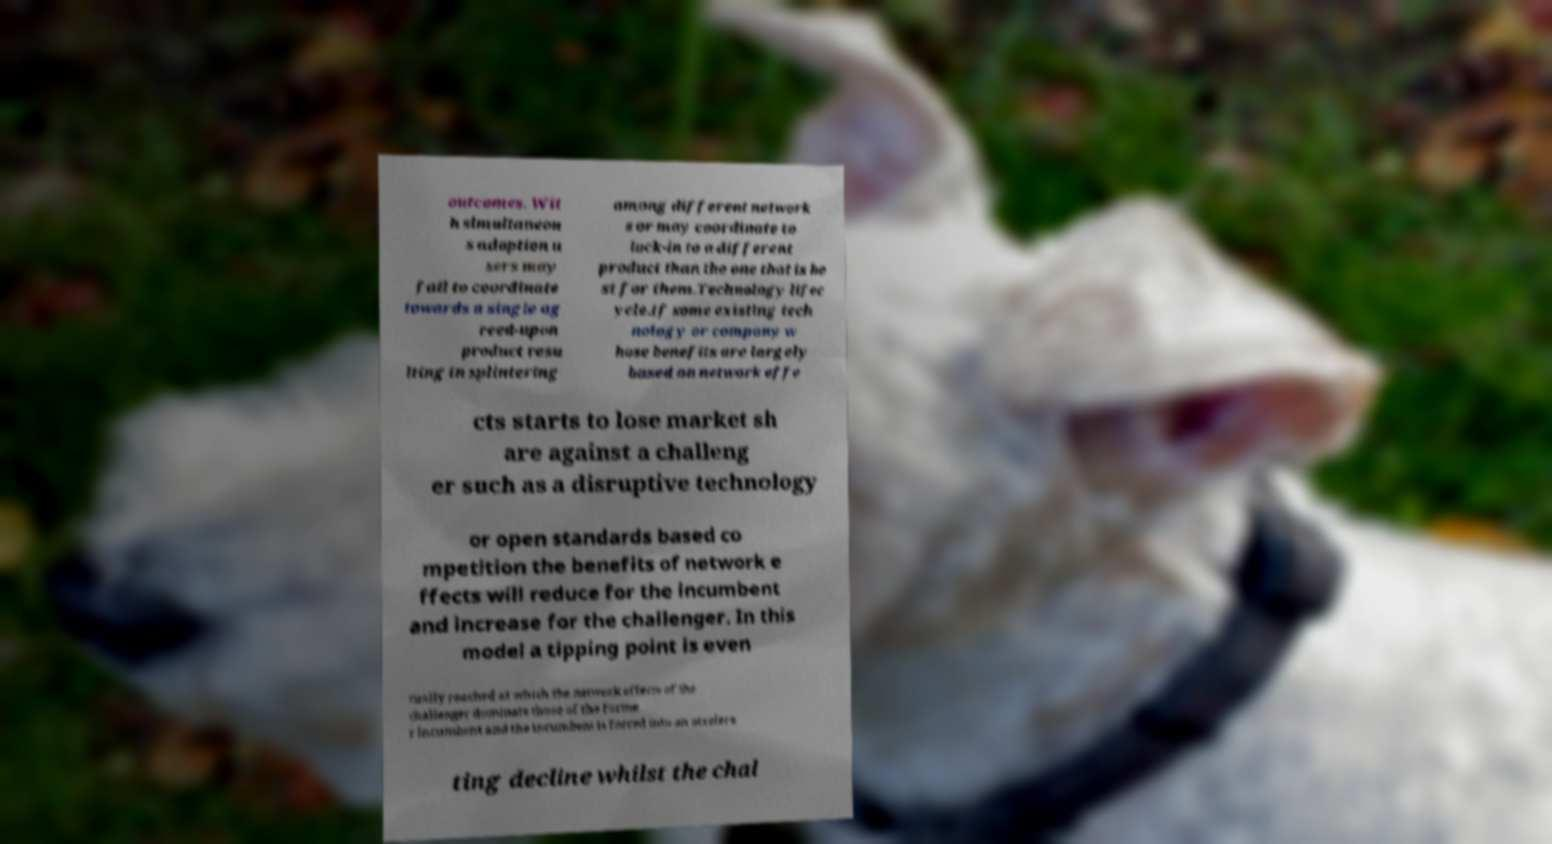Can you read and provide the text displayed in the image?This photo seems to have some interesting text. Can you extract and type it out for me? outcomes. Wit h simultaneou s adoption u sers may fail to coordinate towards a single ag reed-upon product resu lting in splintering among different network s or may coordinate to lock-in to a different product than the one that is be st for them.Technology lifec ycle.If some existing tech nology or company w hose benefits are largely based on network effe cts starts to lose market sh are against a challeng er such as a disruptive technology or open standards based co mpetition the benefits of network e ffects will reduce for the incumbent and increase for the challenger. In this model a tipping point is even tually reached at which the network effects of the challenger dominate those of the forme r incumbent and the incumbent is forced into an accelera ting decline whilst the chal 